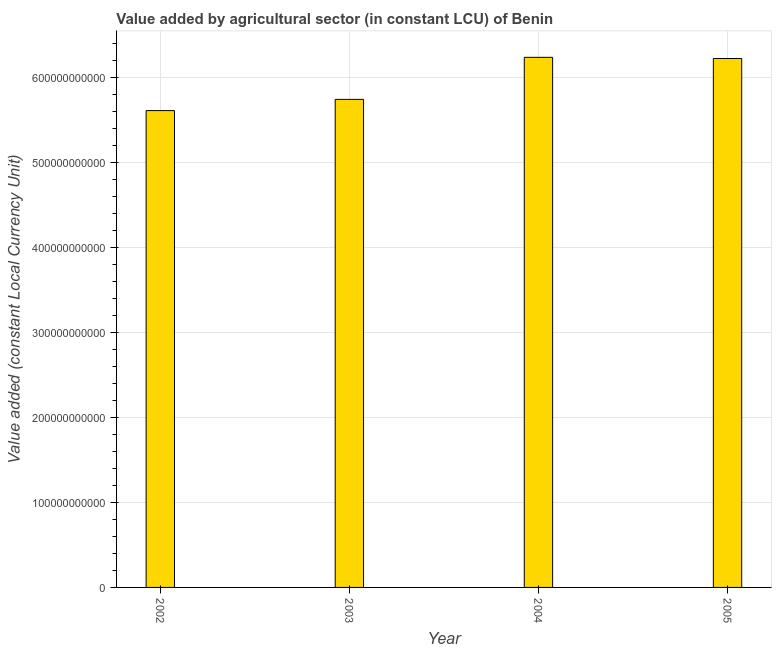Does the graph contain any zero values?
Ensure brevity in your answer.  No. What is the title of the graph?
Offer a terse response. Value added by agricultural sector (in constant LCU) of Benin. What is the label or title of the Y-axis?
Give a very brief answer. Value added (constant Local Currency Unit). What is the value added by agriculture sector in 2002?
Make the answer very short. 5.61e+11. Across all years, what is the maximum value added by agriculture sector?
Make the answer very short. 6.24e+11. Across all years, what is the minimum value added by agriculture sector?
Your answer should be very brief. 5.61e+11. In which year was the value added by agriculture sector minimum?
Provide a short and direct response. 2002. What is the sum of the value added by agriculture sector?
Offer a very short reply. 2.38e+12. What is the difference between the value added by agriculture sector in 2003 and 2004?
Provide a succinct answer. -4.95e+1. What is the average value added by agriculture sector per year?
Ensure brevity in your answer.  5.96e+11. What is the median value added by agriculture sector?
Provide a succinct answer. 5.98e+11. In how many years, is the value added by agriculture sector greater than 580000000000 LCU?
Provide a succinct answer. 2. Do a majority of the years between 2003 and 2004 (inclusive) have value added by agriculture sector greater than 560000000000 LCU?
Give a very brief answer. Yes. What is the ratio of the value added by agriculture sector in 2003 to that in 2004?
Give a very brief answer. 0.92. What is the difference between the highest and the second highest value added by agriculture sector?
Offer a very short reply. 1.40e+09. Is the sum of the value added by agriculture sector in 2002 and 2005 greater than the maximum value added by agriculture sector across all years?
Provide a succinct answer. Yes. What is the difference between the highest and the lowest value added by agriculture sector?
Provide a succinct answer. 6.27e+1. How many bars are there?
Offer a very short reply. 4. Are all the bars in the graph horizontal?
Ensure brevity in your answer.  No. How many years are there in the graph?
Your answer should be compact. 4. What is the difference between two consecutive major ticks on the Y-axis?
Your response must be concise. 1.00e+11. What is the Value added (constant Local Currency Unit) in 2002?
Your answer should be very brief. 5.61e+11. What is the Value added (constant Local Currency Unit) in 2003?
Give a very brief answer. 5.74e+11. What is the Value added (constant Local Currency Unit) of 2004?
Offer a very short reply. 6.24e+11. What is the Value added (constant Local Currency Unit) of 2005?
Your response must be concise. 6.22e+11. What is the difference between the Value added (constant Local Currency Unit) in 2002 and 2003?
Provide a short and direct response. -1.32e+1. What is the difference between the Value added (constant Local Currency Unit) in 2002 and 2004?
Offer a very short reply. -6.27e+1. What is the difference between the Value added (constant Local Currency Unit) in 2002 and 2005?
Your answer should be compact. -6.13e+1. What is the difference between the Value added (constant Local Currency Unit) in 2003 and 2004?
Your answer should be very brief. -4.95e+1. What is the difference between the Value added (constant Local Currency Unit) in 2003 and 2005?
Keep it short and to the point. -4.81e+1. What is the difference between the Value added (constant Local Currency Unit) in 2004 and 2005?
Provide a succinct answer. 1.40e+09. What is the ratio of the Value added (constant Local Currency Unit) in 2002 to that in 2005?
Make the answer very short. 0.9. What is the ratio of the Value added (constant Local Currency Unit) in 2003 to that in 2004?
Ensure brevity in your answer.  0.92. What is the ratio of the Value added (constant Local Currency Unit) in 2003 to that in 2005?
Keep it short and to the point. 0.92. What is the ratio of the Value added (constant Local Currency Unit) in 2004 to that in 2005?
Make the answer very short. 1. 